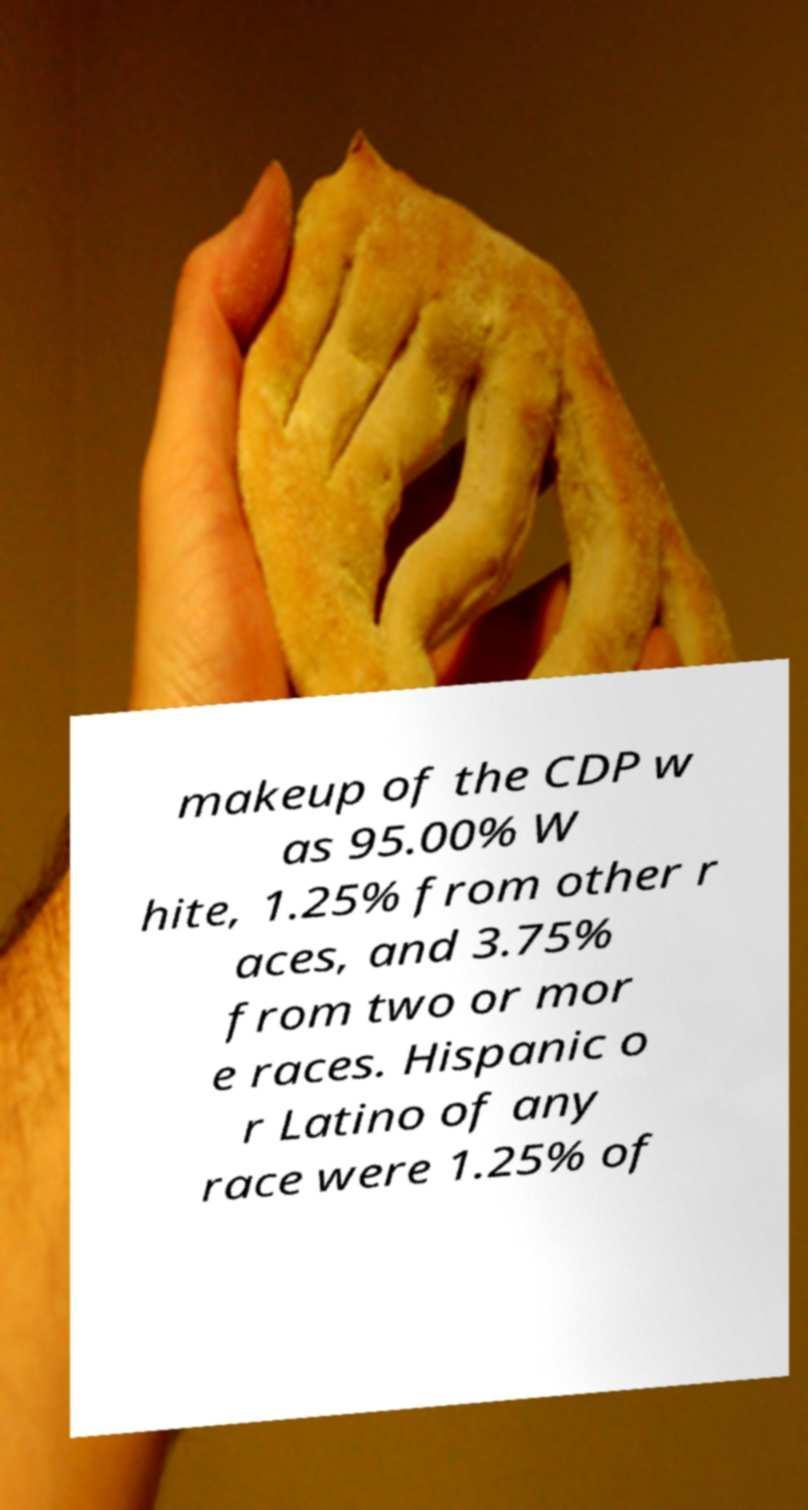Could you assist in decoding the text presented in this image and type it out clearly? makeup of the CDP w as 95.00% W hite, 1.25% from other r aces, and 3.75% from two or mor e races. Hispanic o r Latino of any race were 1.25% of 